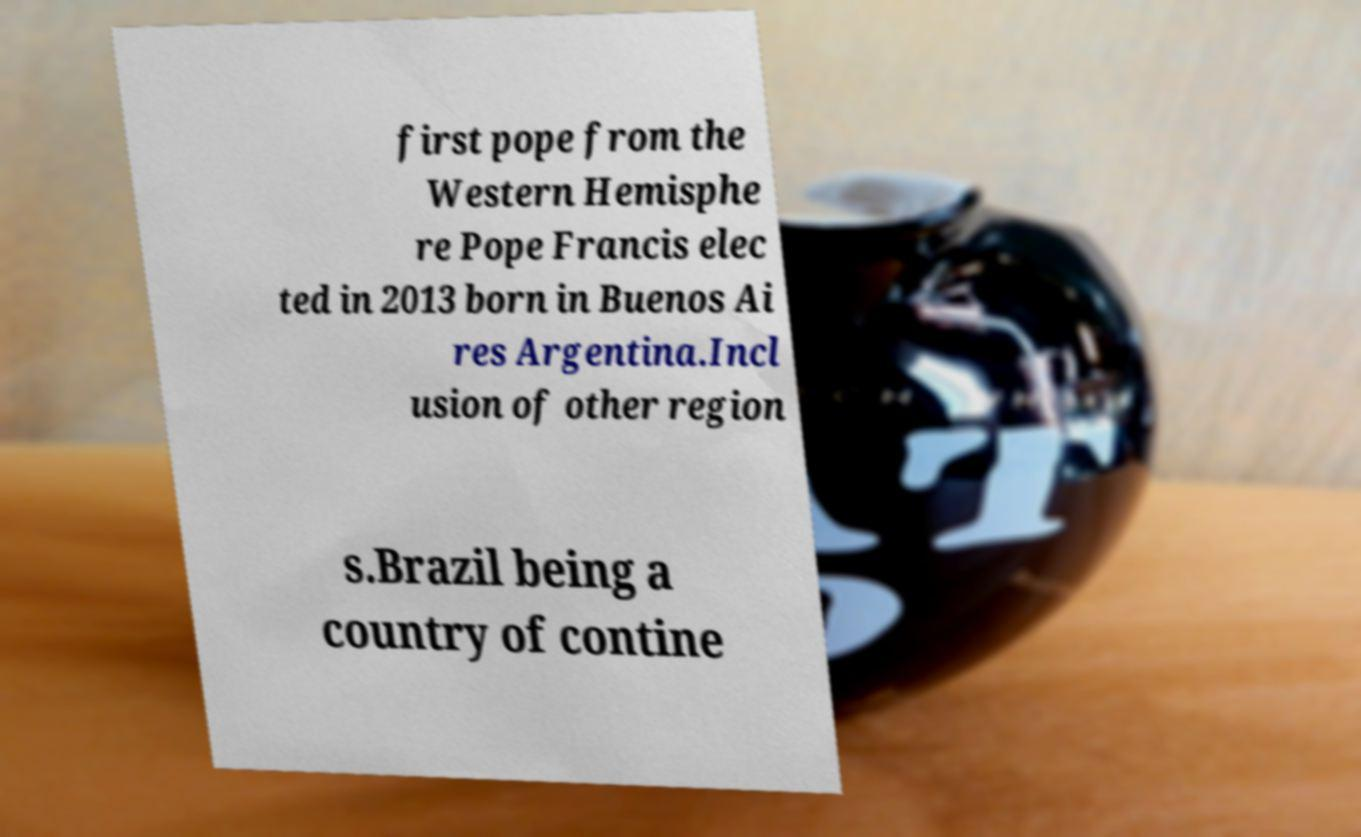There's text embedded in this image that I need extracted. Can you transcribe it verbatim? first pope from the Western Hemisphe re Pope Francis elec ted in 2013 born in Buenos Ai res Argentina.Incl usion of other region s.Brazil being a country of contine 